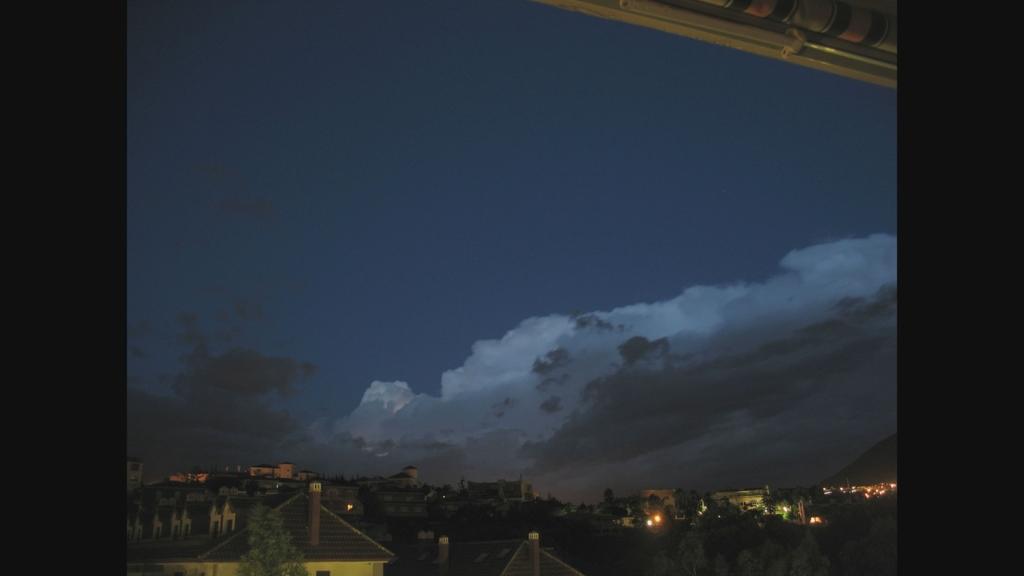How would you summarize this image in a sentence or two? In this image, we can see a few houses. We can see some lights, trees. We can also see the sky with clouds. 